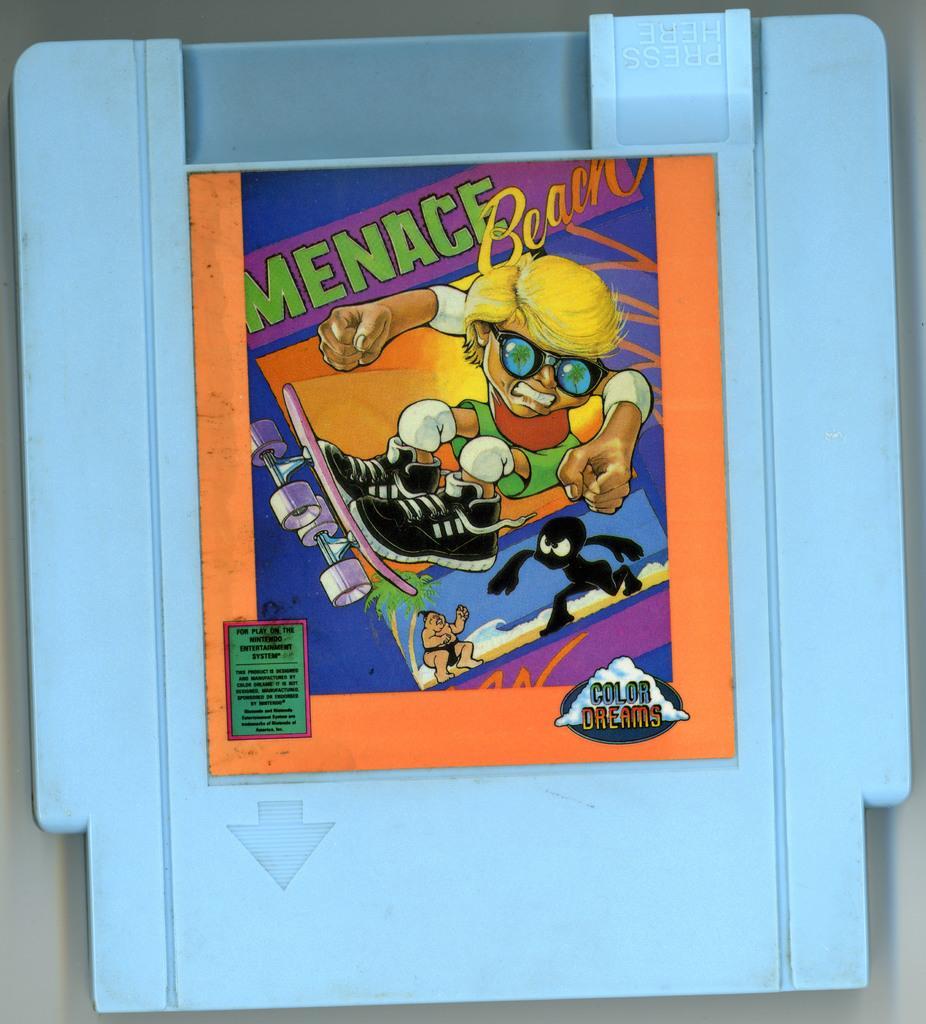Can you describe this image briefly? In this picture, we can see a poster with some text and some images on the blue color object. 